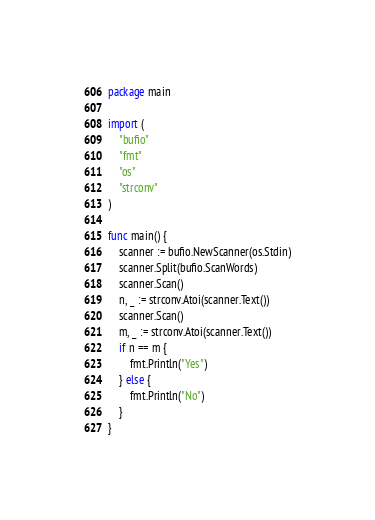Convert code to text. <code><loc_0><loc_0><loc_500><loc_500><_Go_>package main

import (
	"bufio"
	"fmt"
	"os"
	"strconv"
)

func main() {
	scanner := bufio.NewScanner(os.Stdin)
	scanner.Split(bufio.ScanWords)
	scanner.Scan()
	n, _ := strconv.Atoi(scanner.Text())
	scanner.Scan()
	m, _ := strconv.Atoi(scanner.Text())
	if n == m {
		fmt.Println("Yes")
	} else {
		fmt.Println("No")
	}
}
</code> 